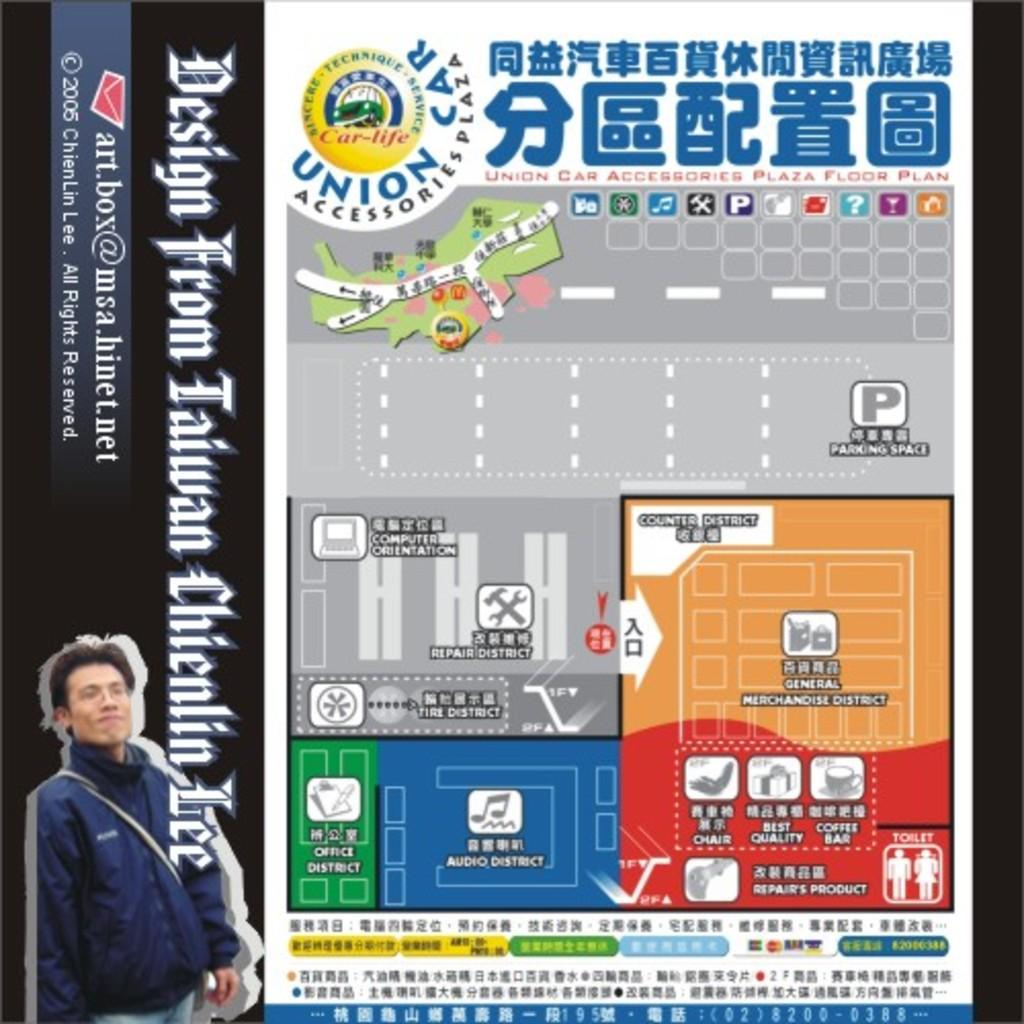<image>
Provide a brief description of the given image. Unicorn car is advertised on the top left of this leaflet. 